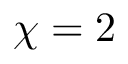Convert formula to latex. <formula><loc_0><loc_0><loc_500><loc_500>\chi = 2</formula> 